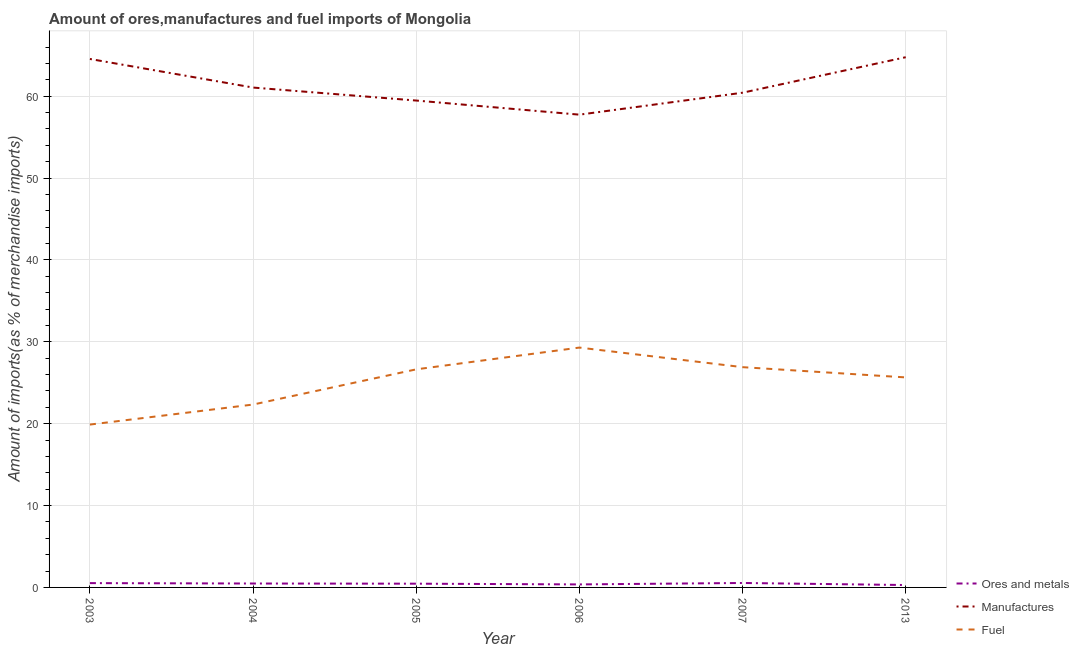What is the percentage of fuel imports in 2013?
Your answer should be very brief. 25.65. Across all years, what is the maximum percentage of manufactures imports?
Your answer should be compact. 64.76. Across all years, what is the minimum percentage of manufactures imports?
Offer a terse response. 57.75. In which year was the percentage of ores and metals imports minimum?
Make the answer very short. 2013. What is the total percentage of ores and metals imports in the graph?
Give a very brief answer. 2.67. What is the difference between the percentage of manufactures imports in 2003 and that in 2004?
Provide a short and direct response. 3.49. What is the difference between the percentage of fuel imports in 2007 and the percentage of ores and metals imports in 2005?
Give a very brief answer. 26.45. What is the average percentage of fuel imports per year?
Your answer should be very brief. 25.12. In the year 2006, what is the difference between the percentage of fuel imports and percentage of manufactures imports?
Your answer should be very brief. -28.45. In how many years, is the percentage of fuel imports greater than 54 %?
Provide a short and direct response. 0. What is the ratio of the percentage of ores and metals imports in 2003 to that in 2005?
Your answer should be very brief. 1.15. Is the percentage of ores and metals imports in 2003 less than that in 2004?
Ensure brevity in your answer.  No. Is the difference between the percentage of manufactures imports in 2003 and 2013 greater than the difference between the percentage of ores and metals imports in 2003 and 2013?
Offer a very short reply. No. What is the difference between the highest and the second highest percentage of ores and metals imports?
Your response must be concise. 0.02. What is the difference between the highest and the lowest percentage of manufactures imports?
Provide a short and direct response. 7.02. Is the percentage of manufactures imports strictly less than the percentage of fuel imports over the years?
Offer a terse response. No. How many lines are there?
Your answer should be very brief. 3. Does the graph contain any zero values?
Keep it short and to the point. No. What is the title of the graph?
Provide a succinct answer. Amount of ores,manufactures and fuel imports of Mongolia. Does "Communicable diseases" appear as one of the legend labels in the graph?
Give a very brief answer. No. What is the label or title of the X-axis?
Offer a terse response. Year. What is the label or title of the Y-axis?
Your response must be concise. Amount of imports(as % of merchandise imports). What is the Amount of imports(as % of merchandise imports) in Ores and metals in 2003?
Offer a terse response. 0.53. What is the Amount of imports(as % of merchandise imports) in Manufactures in 2003?
Make the answer very short. 64.55. What is the Amount of imports(as % of merchandise imports) in Fuel in 2003?
Your answer should be very brief. 19.89. What is the Amount of imports(as % of merchandise imports) in Ores and metals in 2004?
Your response must be concise. 0.48. What is the Amount of imports(as % of merchandise imports) in Manufactures in 2004?
Offer a very short reply. 61.06. What is the Amount of imports(as % of merchandise imports) of Fuel in 2004?
Your answer should be compact. 22.34. What is the Amount of imports(as % of merchandise imports) of Ores and metals in 2005?
Ensure brevity in your answer.  0.46. What is the Amount of imports(as % of merchandise imports) of Manufactures in 2005?
Offer a very short reply. 59.47. What is the Amount of imports(as % of merchandise imports) in Fuel in 2005?
Ensure brevity in your answer.  26.64. What is the Amount of imports(as % of merchandise imports) of Ores and metals in 2006?
Provide a short and direct response. 0.37. What is the Amount of imports(as % of merchandise imports) in Manufactures in 2006?
Your answer should be compact. 57.75. What is the Amount of imports(as % of merchandise imports) in Fuel in 2006?
Offer a very short reply. 29.3. What is the Amount of imports(as % of merchandise imports) in Ores and metals in 2007?
Give a very brief answer. 0.54. What is the Amount of imports(as % of merchandise imports) of Manufactures in 2007?
Offer a very short reply. 60.43. What is the Amount of imports(as % of merchandise imports) of Fuel in 2007?
Ensure brevity in your answer.  26.9. What is the Amount of imports(as % of merchandise imports) in Ores and metals in 2013?
Your answer should be compact. 0.29. What is the Amount of imports(as % of merchandise imports) in Manufactures in 2013?
Provide a succinct answer. 64.76. What is the Amount of imports(as % of merchandise imports) in Fuel in 2013?
Keep it short and to the point. 25.65. Across all years, what is the maximum Amount of imports(as % of merchandise imports) in Ores and metals?
Give a very brief answer. 0.54. Across all years, what is the maximum Amount of imports(as % of merchandise imports) of Manufactures?
Provide a succinct answer. 64.76. Across all years, what is the maximum Amount of imports(as % of merchandise imports) in Fuel?
Your answer should be compact. 29.3. Across all years, what is the minimum Amount of imports(as % of merchandise imports) in Ores and metals?
Give a very brief answer. 0.29. Across all years, what is the minimum Amount of imports(as % of merchandise imports) in Manufactures?
Offer a very short reply. 57.75. Across all years, what is the minimum Amount of imports(as % of merchandise imports) of Fuel?
Give a very brief answer. 19.89. What is the total Amount of imports(as % of merchandise imports) of Ores and metals in the graph?
Ensure brevity in your answer.  2.67. What is the total Amount of imports(as % of merchandise imports) of Manufactures in the graph?
Your answer should be compact. 368.01. What is the total Amount of imports(as % of merchandise imports) of Fuel in the graph?
Make the answer very short. 150.72. What is the difference between the Amount of imports(as % of merchandise imports) of Ores and metals in 2003 and that in 2004?
Ensure brevity in your answer.  0.05. What is the difference between the Amount of imports(as % of merchandise imports) of Manufactures in 2003 and that in 2004?
Provide a succinct answer. 3.49. What is the difference between the Amount of imports(as % of merchandise imports) of Fuel in 2003 and that in 2004?
Offer a terse response. -2.45. What is the difference between the Amount of imports(as % of merchandise imports) of Ores and metals in 2003 and that in 2005?
Provide a succinct answer. 0.07. What is the difference between the Amount of imports(as % of merchandise imports) of Manufactures in 2003 and that in 2005?
Keep it short and to the point. 5.08. What is the difference between the Amount of imports(as % of merchandise imports) of Fuel in 2003 and that in 2005?
Your answer should be very brief. -6.75. What is the difference between the Amount of imports(as % of merchandise imports) in Ores and metals in 2003 and that in 2006?
Offer a terse response. 0.16. What is the difference between the Amount of imports(as % of merchandise imports) in Manufactures in 2003 and that in 2006?
Your answer should be compact. 6.8. What is the difference between the Amount of imports(as % of merchandise imports) of Fuel in 2003 and that in 2006?
Your answer should be compact. -9.41. What is the difference between the Amount of imports(as % of merchandise imports) of Ores and metals in 2003 and that in 2007?
Give a very brief answer. -0.02. What is the difference between the Amount of imports(as % of merchandise imports) in Manufactures in 2003 and that in 2007?
Your answer should be compact. 4.12. What is the difference between the Amount of imports(as % of merchandise imports) in Fuel in 2003 and that in 2007?
Your answer should be very brief. -7.01. What is the difference between the Amount of imports(as % of merchandise imports) of Ores and metals in 2003 and that in 2013?
Your response must be concise. 0.23. What is the difference between the Amount of imports(as % of merchandise imports) in Manufactures in 2003 and that in 2013?
Make the answer very short. -0.21. What is the difference between the Amount of imports(as % of merchandise imports) of Fuel in 2003 and that in 2013?
Your response must be concise. -5.76. What is the difference between the Amount of imports(as % of merchandise imports) in Ores and metals in 2004 and that in 2005?
Offer a very short reply. 0.02. What is the difference between the Amount of imports(as % of merchandise imports) in Manufactures in 2004 and that in 2005?
Offer a very short reply. 1.59. What is the difference between the Amount of imports(as % of merchandise imports) in Fuel in 2004 and that in 2005?
Give a very brief answer. -4.3. What is the difference between the Amount of imports(as % of merchandise imports) of Ores and metals in 2004 and that in 2006?
Provide a succinct answer. 0.11. What is the difference between the Amount of imports(as % of merchandise imports) in Manufactures in 2004 and that in 2006?
Make the answer very short. 3.31. What is the difference between the Amount of imports(as % of merchandise imports) of Fuel in 2004 and that in 2006?
Offer a very short reply. -6.96. What is the difference between the Amount of imports(as % of merchandise imports) in Ores and metals in 2004 and that in 2007?
Your response must be concise. -0.07. What is the difference between the Amount of imports(as % of merchandise imports) in Manufactures in 2004 and that in 2007?
Provide a succinct answer. 0.63. What is the difference between the Amount of imports(as % of merchandise imports) in Fuel in 2004 and that in 2007?
Provide a succinct answer. -4.57. What is the difference between the Amount of imports(as % of merchandise imports) of Ores and metals in 2004 and that in 2013?
Your response must be concise. 0.19. What is the difference between the Amount of imports(as % of merchandise imports) of Manufactures in 2004 and that in 2013?
Your answer should be compact. -3.71. What is the difference between the Amount of imports(as % of merchandise imports) in Fuel in 2004 and that in 2013?
Offer a terse response. -3.31. What is the difference between the Amount of imports(as % of merchandise imports) in Ores and metals in 2005 and that in 2006?
Keep it short and to the point. 0.09. What is the difference between the Amount of imports(as % of merchandise imports) in Manufactures in 2005 and that in 2006?
Your answer should be compact. 1.72. What is the difference between the Amount of imports(as % of merchandise imports) of Fuel in 2005 and that in 2006?
Offer a terse response. -2.66. What is the difference between the Amount of imports(as % of merchandise imports) in Ores and metals in 2005 and that in 2007?
Make the answer very short. -0.09. What is the difference between the Amount of imports(as % of merchandise imports) of Manufactures in 2005 and that in 2007?
Keep it short and to the point. -0.96. What is the difference between the Amount of imports(as % of merchandise imports) in Fuel in 2005 and that in 2007?
Ensure brevity in your answer.  -0.27. What is the difference between the Amount of imports(as % of merchandise imports) in Ores and metals in 2005 and that in 2013?
Your answer should be very brief. 0.17. What is the difference between the Amount of imports(as % of merchandise imports) in Manufactures in 2005 and that in 2013?
Ensure brevity in your answer.  -5.29. What is the difference between the Amount of imports(as % of merchandise imports) in Fuel in 2005 and that in 2013?
Provide a short and direct response. 0.99. What is the difference between the Amount of imports(as % of merchandise imports) of Ores and metals in 2006 and that in 2007?
Give a very brief answer. -0.18. What is the difference between the Amount of imports(as % of merchandise imports) of Manufactures in 2006 and that in 2007?
Ensure brevity in your answer.  -2.68. What is the difference between the Amount of imports(as % of merchandise imports) of Fuel in 2006 and that in 2007?
Offer a very short reply. 2.39. What is the difference between the Amount of imports(as % of merchandise imports) of Ores and metals in 2006 and that in 2013?
Provide a short and direct response. 0.07. What is the difference between the Amount of imports(as % of merchandise imports) in Manufactures in 2006 and that in 2013?
Ensure brevity in your answer.  -7.02. What is the difference between the Amount of imports(as % of merchandise imports) of Fuel in 2006 and that in 2013?
Your answer should be compact. 3.64. What is the difference between the Amount of imports(as % of merchandise imports) in Ores and metals in 2007 and that in 2013?
Offer a terse response. 0.25. What is the difference between the Amount of imports(as % of merchandise imports) of Manufactures in 2007 and that in 2013?
Your answer should be very brief. -4.33. What is the difference between the Amount of imports(as % of merchandise imports) in Fuel in 2007 and that in 2013?
Your response must be concise. 1.25. What is the difference between the Amount of imports(as % of merchandise imports) in Ores and metals in 2003 and the Amount of imports(as % of merchandise imports) in Manufactures in 2004?
Give a very brief answer. -60.53. What is the difference between the Amount of imports(as % of merchandise imports) in Ores and metals in 2003 and the Amount of imports(as % of merchandise imports) in Fuel in 2004?
Give a very brief answer. -21.81. What is the difference between the Amount of imports(as % of merchandise imports) of Manufactures in 2003 and the Amount of imports(as % of merchandise imports) of Fuel in 2004?
Your answer should be compact. 42.21. What is the difference between the Amount of imports(as % of merchandise imports) in Ores and metals in 2003 and the Amount of imports(as % of merchandise imports) in Manufactures in 2005?
Provide a succinct answer. -58.94. What is the difference between the Amount of imports(as % of merchandise imports) in Ores and metals in 2003 and the Amount of imports(as % of merchandise imports) in Fuel in 2005?
Your answer should be very brief. -26.11. What is the difference between the Amount of imports(as % of merchandise imports) of Manufactures in 2003 and the Amount of imports(as % of merchandise imports) of Fuel in 2005?
Give a very brief answer. 37.91. What is the difference between the Amount of imports(as % of merchandise imports) of Ores and metals in 2003 and the Amount of imports(as % of merchandise imports) of Manufactures in 2006?
Ensure brevity in your answer.  -57.22. What is the difference between the Amount of imports(as % of merchandise imports) in Ores and metals in 2003 and the Amount of imports(as % of merchandise imports) in Fuel in 2006?
Provide a succinct answer. -28.77. What is the difference between the Amount of imports(as % of merchandise imports) in Manufactures in 2003 and the Amount of imports(as % of merchandise imports) in Fuel in 2006?
Give a very brief answer. 35.25. What is the difference between the Amount of imports(as % of merchandise imports) in Ores and metals in 2003 and the Amount of imports(as % of merchandise imports) in Manufactures in 2007?
Keep it short and to the point. -59.9. What is the difference between the Amount of imports(as % of merchandise imports) in Ores and metals in 2003 and the Amount of imports(as % of merchandise imports) in Fuel in 2007?
Keep it short and to the point. -26.38. What is the difference between the Amount of imports(as % of merchandise imports) in Manufactures in 2003 and the Amount of imports(as % of merchandise imports) in Fuel in 2007?
Your answer should be very brief. 37.64. What is the difference between the Amount of imports(as % of merchandise imports) in Ores and metals in 2003 and the Amount of imports(as % of merchandise imports) in Manufactures in 2013?
Your answer should be compact. -64.24. What is the difference between the Amount of imports(as % of merchandise imports) of Ores and metals in 2003 and the Amount of imports(as % of merchandise imports) of Fuel in 2013?
Provide a succinct answer. -25.13. What is the difference between the Amount of imports(as % of merchandise imports) of Manufactures in 2003 and the Amount of imports(as % of merchandise imports) of Fuel in 2013?
Ensure brevity in your answer.  38.89. What is the difference between the Amount of imports(as % of merchandise imports) of Ores and metals in 2004 and the Amount of imports(as % of merchandise imports) of Manufactures in 2005?
Offer a terse response. -58.99. What is the difference between the Amount of imports(as % of merchandise imports) of Ores and metals in 2004 and the Amount of imports(as % of merchandise imports) of Fuel in 2005?
Provide a short and direct response. -26.16. What is the difference between the Amount of imports(as % of merchandise imports) of Manufactures in 2004 and the Amount of imports(as % of merchandise imports) of Fuel in 2005?
Your answer should be very brief. 34.42. What is the difference between the Amount of imports(as % of merchandise imports) in Ores and metals in 2004 and the Amount of imports(as % of merchandise imports) in Manufactures in 2006?
Provide a short and direct response. -57.27. What is the difference between the Amount of imports(as % of merchandise imports) of Ores and metals in 2004 and the Amount of imports(as % of merchandise imports) of Fuel in 2006?
Your answer should be compact. -28.82. What is the difference between the Amount of imports(as % of merchandise imports) of Manufactures in 2004 and the Amount of imports(as % of merchandise imports) of Fuel in 2006?
Provide a short and direct response. 31.76. What is the difference between the Amount of imports(as % of merchandise imports) of Ores and metals in 2004 and the Amount of imports(as % of merchandise imports) of Manufactures in 2007?
Your answer should be compact. -59.95. What is the difference between the Amount of imports(as % of merchandise imports) of Ores and metals in 2004 and the Amount of imports(as % of merchandise imports) of Fuel in 2007?
Ensure brevity in your answer.  -26.43. What is the difference between the Amount of imports(as % of merchandise imports) of Manufactures in 2004 and the Amount of imports(as % of merchandise imports) of Fuel in 2007?
Make the answer very short. 34.15. What is the difference between the Amount of imports(as % of merchandise imports) in Ores and metals in 2004 and the Amount of imports(as % of merchandise imports) in Manufactures in 2013?
Provide a short and direct response. -64.28. What is the difference between the Amount of imports(as % of merchandise imports) of Ores and metals in 2004 and the Amount of imports(as % of merchandise imports) of Fuel in 2013?
Keep it short and to the point. -25.17. What is the difference between the Amount of imports(as % of merchandise imports) in Manufactures in 2004 and the Amount of imports(as % of merchandise imports) in Fuel in 2013?
Provide a succinct answer. 35.4. What is the difference between the Amount of imports(as % of merchandise imports) in Ores and metals in 2005 and the Amount of imports(as % of merchandise imports) in Manufactures in 2006?
Provide a succinct answer. -57.29. What is the difference between the Amount of imports(as % of merchandise imports) of Ores and metals in 2005 and the Amount of imports(as % of merchandise imports) of Fuel in 2006?
Provide a short and direct response. -28.84. What is the difference between the Amount of imports(as % of merchandise imports) in Manufactures in 2005 and the Amount of imports(as % of merchandise imports) in Fuel in 2006?
Provide a succinct answer. 30.17. What is the difference between the Amount of imports(as % of merchandise imports) in Ores and metals in 2005 and the Amount of imports(as % of merchandise imports) in Manufactures in 2007?
Your answer should be compact. -59.97. What is the difference between the Amount of imports(as % of merchandise imports) in Ores and metals in 2005 and the Amount of imports(as % of merchandise imports) in Fuel in 2007?
Your response must be concise. -26.45. What is the difference between the Amount of imports(as % of merchandise imports) in Manufactures in 2005 and the Amount of imports(as % of merchandise imports) in Fuel in 2007?
Ensure brevity in your answer.  32.57. What is the difference between the Amount of imports(as % of merchandise imports) in Ores and metals in 2005 and the Amount of imports(as % of merchandise imports) in Manufactures in 2013?
Give a very brief answer. -64.3. What is the difference between the Amount of imports(as % of merchandise imports) of Ores and metals in 2005 and the Amount of imports(as % of merchandise imports) of Fuel in 2013?
Keep it short and to the point. -25.2. What is the difference between the Amount of imports(as % of merchandise imports) of Manufactures in 2005 and the Amount of imports(as % of merchandise imports) of Fuel in 2013?
Your response must be concise. 33.82. What is the difference between the Amount of imports(as % of merchandise imports) in Ores and metals in 2006 and the Amount of imports(as % of merchandise imports) in Manufactures in 2007?
Offer a terse response. -60.06. What is the difference between the Amount of imports(as % of merchandise imports) of Ores and metals in 2006 and the Amount of imports(as % of merchandise imports) of Fuel in 2007?
Make the answer very short. -26.54. What is the difference between the Amount of imports(as % of merchandise imports) in Manufactures in 2006 and the Amount of imports(as % of merchandise imports) in Fuel in 2007?
Ensure brevity in your answer.  30.84. What is the difference between the Amount of imports(as % of merchandise imports) in Ores and metals in 2006 and the Amount of imports(as % of merchandise imports) in Manufactures in 2013?
Your answer should be very brief. -64.39. What is the difference between the Amount of imports(as % of merchandise imports) of Ores and metals in 2006 and the Amount of imports(as % of merchandise imports) of Fuel in 2013?
Make the answer very short. -25.29. What is the difference between the Amount of imports(as % of merchandise imports) of Manufactures in 2006 and the Amount of imports(as % of merchandise imports) of Fuel in 2013?
Provide a short and direct response. 32.09. What is the difference between the Amount of imports(as % of merchandise imports) in Ores and metals in 2007 and the Amount of imports(as % of merchandise imports) in Manufactures in 2013?
Make the answer very short. -64.22. What is the difference between the Amount of imports(as % of merchandise imports) of Ores and metals in 2007 and the Amount of imports(as % of merchandise imports) of Fuel in 2013?
Offer a terse response. -25.11. What is the difference between the Amount of imports(as % of merchandise imports) of Manufactures in 2007 and the Amount of imports(as % of merchandise imports) of Fuel in 2013?
Provide a succinct answer. 34.77. What is the average Amount of imports(as % of merchandise imports) in Ores and metals per year?
Offer a terse response. 0.44. What is the average Amount of imports(as % of merchandise imports) of Manufactures per year?
Provide a short and direct response. 61.33. What is the average Amount of imports(as % of merchandise imports) in Fuel per year?
Provide a succinct answer. 25.12. In the year 2003, what is the difference between the Amount of imports(as % of merchandise imports) of Ores and metals and Amount of imports(as % of merchandise imports) of Manufactures?
Ensure brevity in your answer.  -64.02. In the year 2003, what is the difference between the Amount of imports(as % of merchandise imports) in Ores and metals and Amount of imports(as % of merchandise imports) in Fuel?
Keep it short and to the point. -19.36. In the year 2003, what is the difference between the Amount of imports(as % of merchandise imports) of Manufactures and Amount of imports(as % of merchandise imports) of Fuel?
Offer a terse response. 44.66. In the year 2004, what is the difference between the Amount of imports(as % of merchandise imports) in Ores and metals and Amount of imports(as % of merchandise imports) in Manufactures?
Give a very brief answer. -60.58. In the year 2004, what is the difference between the Amount of imports(as % of merchandise imports) in Ores and metals and Amount of imports(as % of merchandise imports) in Fuel?
Offer a terse response. -21.86. In the year 2004, what is the difference between the Amount of imports(as % of merchandise imports) in Manufactures and Amount of imports(as % of merchandise imports) in Fuel?
Your answer should be compact. 38.72. In the year 2005, what is the difference between the Amount of imports(as % of merchandise imports) of Ores and metals and Amount of imports(as % of merchandise imports) of Manufactures?
Your response must be concise. -59.01. In the year 2005, what is the difference between the Amount of imports(as % of merchandise imports) in Ores and metals and Amount of imports(as % of merchandise imports) in Fuel?
Your answer should be compact. -26.18. In the year 2005, what is the difference between the Amount of imports(as % of merchandise imports) of Manufactures and Amount of imports(as % of merchandise imports) of Fuel?
Ensure brevity in your answer.  32.83. In the year 2006, what is the difference between the Amount of imports(as % of merchandise imports) of Ores and metals and Amount of imports(as % of merchandise imports) of Manufactures?
Your response must be concise. -57.38. In the year 2006, what is the difference between the Amount of imports(as % of merchandise imports) of Ores and metals and Amount of imports(as % of merchandise imports) of Fuel?
Your response must be concise. -28.93. In the year 2006, what is the difference between the Amount of imports(as % of merchandise imports) of Manufactures and Amount of imports(as % of merchandise imports) of Fuel?
Your answer should be very brief. 28.45. In the year 2007, what is the difference between the Amount of imports(as % of merchandise imports) in Ores and metals and Amount of imports(as % of merchandise imports) in Manufactures?
Offer a terse response. -59.88. In the year 2007, what is the difference between the Amount of imports(as % of merchandise imports) in Ores and metals and Amount of imports(as % of merchandise imports) in Fuel?
Provide a succinct answer. -26.36. In the year 2007, what is the difference between the Amount of imports(as % of merchandise imports) of Manufactures and Amount of imports(as % of merchandise imports) of Fuel?
Keep it short and to the point. 33.52. In the year 2013, what is the difference between the Amount of imports(as % of merchandise imports) of Ores and metals and Amount of imports(as % of merchandise imports) of Manufactures?
Ensure brevity in your answer.  -64.47. In the year 2013, what is the difference between the Amount of imports(as % of merchandise imports) of Ores and metals and Amount of imports(as % of merchandise imports) of Fuel?
Offer a very short reply. -25.36. In the year 2013, what is the difference between the Amount of imports(as % of merchandise imports) in Manufactures and Amount of imports(as % of merchandise imports) in Fuel?
Offer a terse response. 39.11. What is the ratio of the Amount of imports(as % of merchandise imports) in Ores and metals in 2003 to that in 2004?
Provide a short and direct response. 1.1. What is the ratio of the Amount of imports(as % of merchandise imports) in Manufactures in 2003 to that in 2004?
Give a very brief answer. 1.06. What is the ratio of the Amount of imports(as % of merchandise imports) in Fuel in 2003 to that in 2004?
Your response must be concise. 0.89. What is the ratio of the Amount of imports(as % of merchandise imports) in Ores and metals in 2003 to that in 2005?
Your answer should be compact. 1.15. What is the ratio of the Amount of imports(as % of merchandise imports) of Manufactures in 2003 to that in 2005?
Ensure brevity in your answer.  1.09. What is the ratio of the Amount of imports(as % of merchandise imports) in Fuel in 2003 to that in 2005?
Provide a short and direct response. 0.75. What is the ratio of the Amount of imports(as % of merchandise imports) in Ores and metals in 2003 to that in 2006?
Provide a succinct answer. 1.44. What is the ratio of the Amount of imports(as % of merchandise imports) of Manufactures in 2003 to that in 2006?
Your answer should be very brief. 1.12. What is the ratio of the Amount of imports(as % of merchandise imports) in Fuel in 2003 to that in 2006?
Offer a terse response. 0.68. What is the ratio of the Amount of imports(as % of merchandise imports) of Ores and metals in 2003 to that in 2007?
Keep it short and to the point. 0.97. What is the ratio of the Amount of imports(as % of merchandise imports) in Manufactures in 2003 to that in 2007?
Offer a very short reply. 1.07. What is the ratio of the Amount of imports(as % of merchandise imports) of Fuel in 2003 to that in 2007?
Provide a short and direct response. 0.74. What is the ratio of the Amount of imports(as % of merchandise imports) in Ores and metals in 2003 to that in 2013?
Make the answer very short. 1.8. What is the ratio of the Amount of imports(as % of merchandise imports) of Manufactures in 2003 to that in 2013?
Offer a terse response. 1. What is the ratio of the Amount of imports(as % of merchandise imports) in Fuel in 2003 to that in 2013?
Your response must be concise. 0.78. What is the ratio of the Amount of imports(as % of merchandise imports) of Ores and metals in 2004 to that in 2005?
Give a very brief answer. 1.04. What is the ratio of the Amount of imports(as % of merchandise imports) of Manufactures in 2004 to that in 2005?
Provide a succinct answer. 1.03. What is the ratio of the Amount of imports(as % of merchandise imports) in Fuel in 2004 to that in 2005?
Provide a short and direct response. 0.84. What is the ratio of the Amount of imports(as % of merchandise imports) in Ores and metals in 2004 to that in 2006?
Offer a terse response. 1.3. What is the ratio of the Amount of imports(as % of merchandise imports) in Manufactures in 2004 to that in 2006?
Keep it short and to the point. 1.06. What is the ratio of the Amount of imports(as % of merchandise imports) of Fuel in 2004 to that in 2006?
Ensure brevity in your answer.  0.76. What is the ratio of the Amount of imports(as % of merchandise imports) of Ores and metals in 2004 to that in 2007?
Provide a succinct answer. 0.88. What is the ratio of the Amount of imports(as % of merchandise imports) of Manufactures in 2004 to that in 2007?
Make the answer very short. 1.01. What is the ratio of the Amount of imports(as % of merchandise imports) in Fuel in 2004 to that in 2007?
Provide a short and direct response. 0.83. What is the ratio of the Amount of imports(as % of merchandise imports) in Ores and metals in 2004 to that in 2013?
Provide a short and direct response. 1.64. What is the ratio of the Amount of imports(as % of merchandise imports) of Manufactures in 2004 to that in 2013?
Provide a short and direct response. 0.94. What is the ratio of the Amount of imports(as % of merchandise imports) in Fuel in 2004 to that in 2013?
Offer a terse response. 0.87. What is the ratio of the Amount of imports(as % of merchandise imports) in Ores and metals in 2005 to that in 2006?
Keep it short and to the point. 1.25. What is the ratio of the Amount of imports(as % of merchandise imports) in Manufactures in 2005 to that in 2006?
Give a very brief answer. 1.03. What is the ratio of the Amount of imports(as % of merchandise imports) of Fuel in 2005 to that in 2006?
Provide a short and direct response. 0.91. What is the ratio of the Amount of imports(as % of merchandise imports) of Ores and metals in 2005 to that in 2007?
Provide a short and direct response. 0.84. What is the ratio of the Amount of imports(as % of merchandise imports) in Manufactures in 2005 to that in 2007?
Provide a succinct answer. 0.98. What is the ratio of the Amount of imports(as % of merchandise imports) in Ores and metals in 2005 to that in 2013?
Offer a terse response. 1.57. What is the ratio of the Amount of imports(as % of merchandise imports) of Manufactures in 2005 to that in 2013?
Provide a short and direct response. 0.92. What is the ratio of the Amount of imports(as % of merchandise imports) of Fuel in 2005 to that in 2013?
Give a very brief answer. 1.04. What is the ratio of the Amount of imports(as % of merchandise imports) of Ores and metals in 2006 to that in 2007?
Make the answer very short. 0.68. What is the ratio of the Amount of imports(as % of merchandise imports) in Manufactures in 2006 to that in 2007?
Provide a short and direct response. 0.96. What is the ratio of the Amount of imports(as % of merchandise imports) of Fuel in 2006 to that in 2007?
Your answer should be very brief. 1.09. What is the ratio of the Amount of imports(as % of merchandise imports) of Ores and metals in 2006 to that in 2013?
Keep it short and to the point. 1.26. What is the ratio of the Amount of imports(as % of merchandise imports) of Manufactures in 2006 to that in 2013?
Give a very brief answer. 0.89. What is the ratio of the Amount of imports(as % of merchandise imports) of Fuel in 2006 to that in 2013?
Your answer should be very brief. 1.14. What is the ratio of the Amount of imports(as % of merchandise imports) of Ores and metals in 2007 to that in 2013?
Offer a very short reply. 1.86. What is the ratio of the Amount of imports(as % of merchandise imports) in Manufactures in 2007 to that in 2013?
Offer a terse response. 0.93. What is the ratio of the Amount of imports(as % of merchandise imports) of Fuel in 2007 to that in 2013?
Your answer should be very brief. 1.05. What is the difference between the highest and the second highest Amount of imports(as % of merchandise imports) of Ores and metals?
Offer a very short reply. 0.02. What is the difference between the highest and the second highest Amount of imports(as % of merchandise imports) of Manufactures?
Give a very brief answer. 0.21. What is the difference between the highest and the second highest Amount of imports(as % of merchandise imports) in Fuel?
Give a very brief answer. 2.39. What is the difference between the highest and the lowest Amount of imports(as % of merchandise imports) in Ores and metals?
Keep it short and to the point. 0.25. What is the difference between the highest and the lowest Amount of imports(as % of merchandise imports) of Manufactures?
Provide a short and direct response. 7.02. What is the difference between the highest and the lowest Amount of imports(as % of merchandise imports) of Fuel?
Provide a short and direct response. 9.41. 